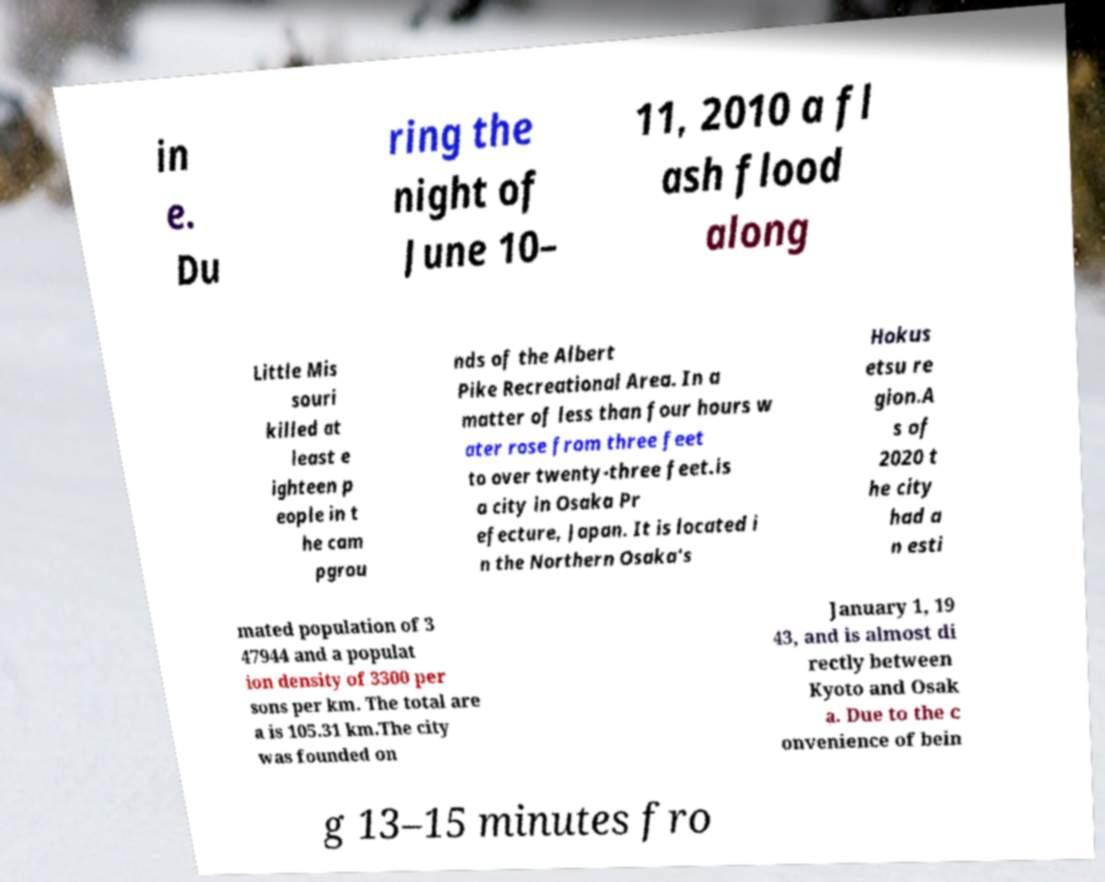For documentation purposes, I need the text within this image transcribed. Could you provide that? in e. Du ring the night of June 10– 11, 2010 a fl ash flood along Little Mis souri killed at least e ighteen p eople in t he cam pgrou nds of the Albert Pike Recreational Area. In a matter of less than four hours w ater rose from three feet to over twenty-three feet.is a city in Osaka Pr efecture, Japan. It is located i n the Northern Osaka's Hokus etsu re gion.A s of 2020 t he city had a n esti mated population of 3 47944 and a populat ion density of 3300 per sons per km. The total are a is 105.31 km.The city was founded on January 1, 19 43, and is almost di rectly between Kyoto and Osak a. Due to the c onvenience of bein g 13–15 minutes fro 